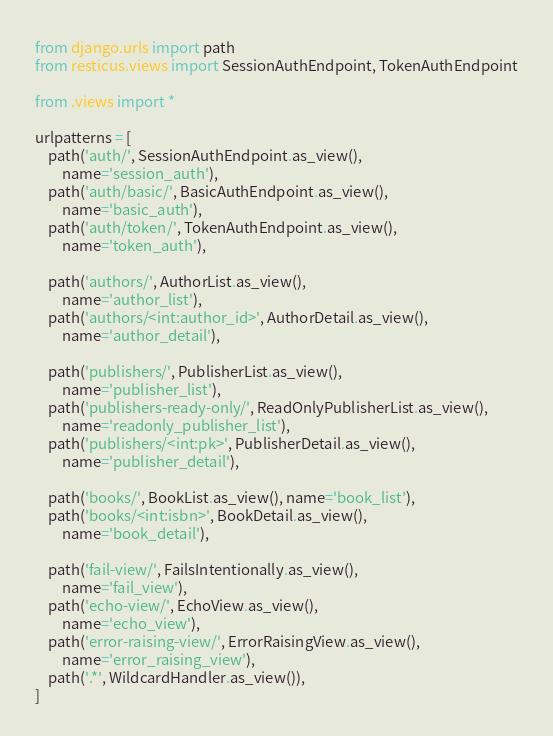<code> <loc_0><loc_0><loc_500><loc_500><_Python_>from django.urls import path
from resticus.views import SessionAuthEndpoint, TokenAuthEndpoint

from .views import *

urlpatterns = [
    path('auth/', SessionAuthEndpoint.as_view(),
        name='session_auth'),
    path('auth/basic/', BasicAuthEndpoint.as_view(),
        name='basic_auth'),
    path('auth/token/', TokenAuthEndpoint.as_view(),
        name='token_auth'),

    path('authors/', AuthorList.as_view(),
        name='author_list'),
    path('authors/<int:author_id>', AuthorDetail.as_view(),
        name='author_detail'),

    path('publishers/', PublisherList.as_view(),
        name='publisher_list'),
    path('publishers-ready-only/', ReadOnlyPublisherList.as_view(),
        name='readonly_publisher_list'),
    path('publishers/<int:pk>', PublisherDetail.as_view(),
        name='publisher_detail'),

    path('books/', BookList.as_view(), name='book_list'),
    path('books/<int:isbn>', BookDetail.as_view(),
        name='book_detail'),

    path('fail-view/', FailsIntentionally.as_view(),
        name='fail_view'),
    path('echo-view/', EchoView.as_view(),
        name='echo_view'),
    path('error-raising-view/', ErrorRaisingView.as_view(),
        name='error_raising_view'),
    path('.*', WildcardHandler.as_view()),
]
</code> 